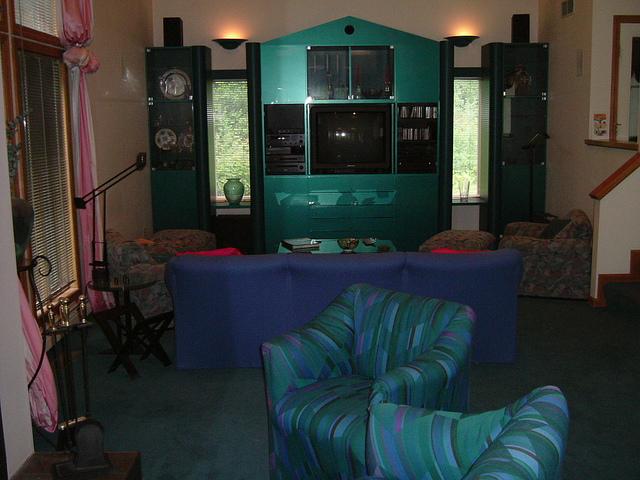Are the lamps above the windows lit or off?
Quick response, please. Lit. What color is the carpet?
Answer briefly. Blue. What is it so dark in this room?
Give a very brief answer. Dim lights. What color is the pillow?
Concise answer only. Red. What color is the sofa?
Answer briefly. Blue. What pattern is on the couch?
Concise answer only. Stripes. Is the furniture covered in fabric?
Keep it brief. Yes. Is the couch stupid?
Answer briefly. No. Are there any stairs leading from this room?
Quick response, please. Yes. 